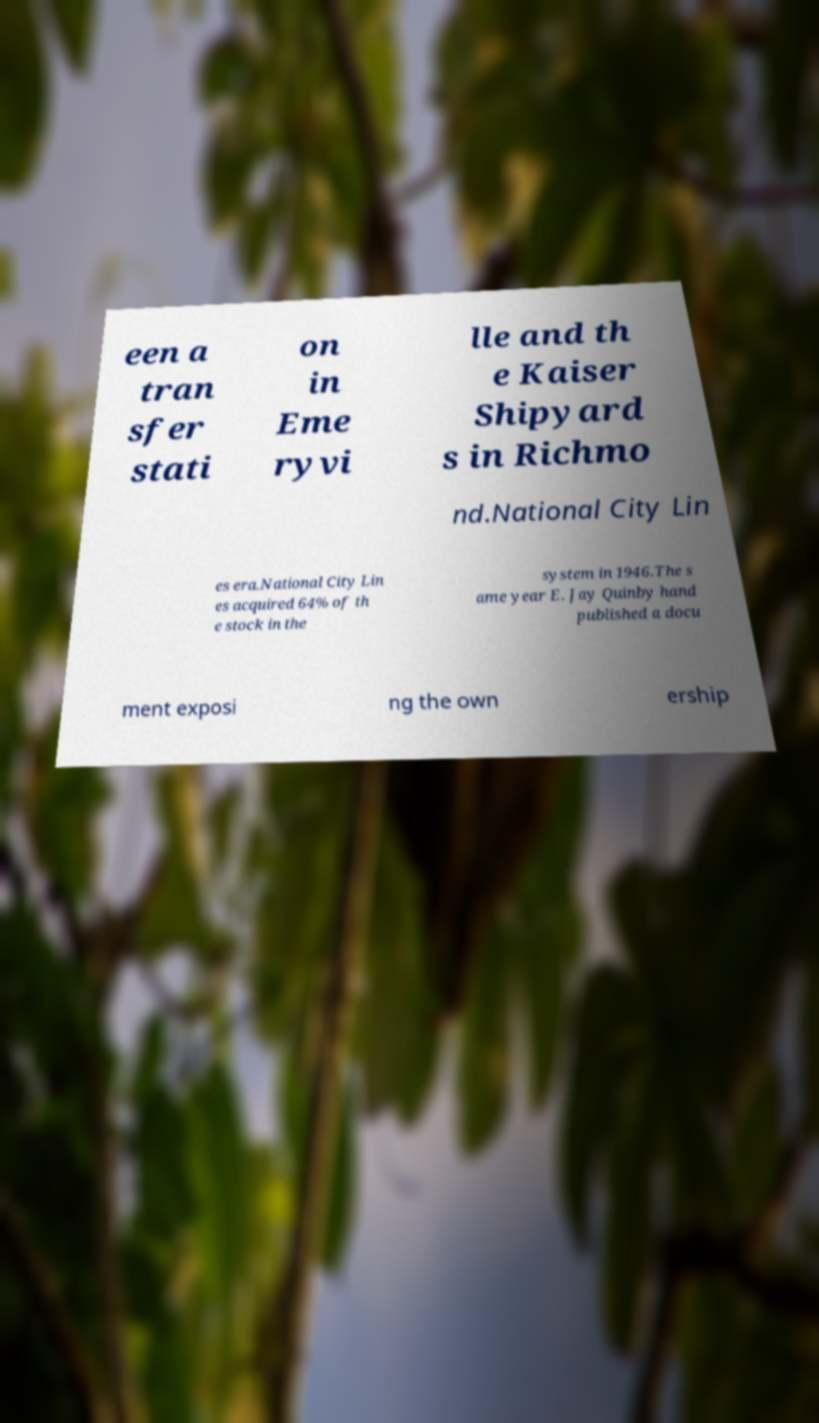Could you extract and type out the text from this image? een a tran sfer stati on in Eme ryvi lle and th e Kaiser Shipyard s in Richmo nd.National City Lin es era.National City Lin es acquired 64% of th e stock in the system in 1946.The s ame year E. Jay Quinby hand published a docu ment exposi ng the own ership 